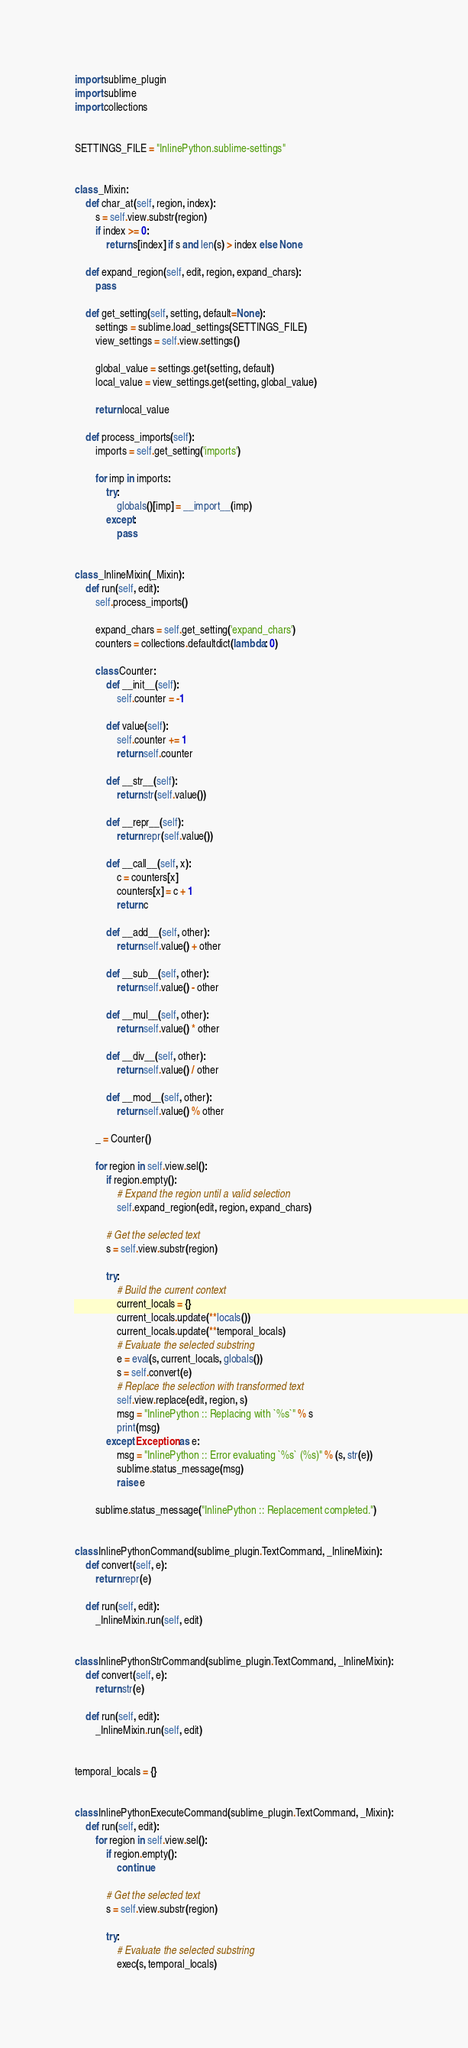<code> <loc_0><loc_0><loc_500><loc_500><_Python_>import sublime_plugin
import sublime
import collections


SETTINGS_FILE = "InlinePython.sublime-settings"


class _Mixin:
    def char_at(self, region, index):
        s = self.view.substr(region)
        if index >= 0:
            return s[index] if s and len(s) > index else None

    def expand_region(self, edit, region, expand_chars):
        pass

    def get_setting(self, setting, default=None):
        settings = sublime.load_settings(SETTINGS_FILE)
        view_settings = self.view.settings()

        global_value = settings.get(setting, default)
        local_value = view_settings.get(setting, global_value)

        return local_value

    def process_imports(self):
        imports = self.get_setting('imports')

        for imp in imports:
            try:
                globals()[imp] = __import__(imp)
            except:
                pass


class _InlineMixin(_Mixin):
    def run(self, edit):
        self.process_imports()

        expand_chars = self.get_setting('expand_chars')
        counters = collections.defaultdict(lambda: 0)

        class Counter:
            def __init__(self):
                self.counter = -1

            def value(self):
                self.counter += 1
                return self.counter

            def __str__(self):
                return str(self.value())

            def __repr__(self):
                return repr(self.value())

            def __call__(self, x):
                c = counters[x]
                counters[x] = c + 1
                return c

            def __add__(self, other):
                return self.value() + other

            def __sub__(self, other):
                return self.value() - other

            def __mul__(self, other):
                return self.value() * other

            def __div__(self, other):
                return self.value() / other

            def __mod__(self, other):
                return self.value() % other

        _ = Counter()

        for region in self.view.sel():
            if region.empty():
                # Expand the region until a valid selection
                self.expand_region(edit, region, expand_chars)

            # Get the selected text
            s = self.view.substr(region)

            try:
                # Build the current context
                current_locals = {}
                current_locals.update(**locals())
                current_locals.update(**temporal_locals)
                # Evaluate the selected substring
                e = eval(s, current_locals, globals())
                s = self.convert(e)
                # Replace the selection with transformed text
                self.view.replace(edit, region, s)
                msg = "InlinePython :: Replacing with `%s`" % s
                print(msg)
            except Exception as e:
                msg = "InlinePython :: Error evaluating `%s` (%s)" % (s, str(e))
                sublime.status_message(msg)
                raise e

        sublime.status_message("InlinePython :: Replacement completed.")


class InlinePythonCommand(sublime_plugin.TextCommand, _InlineMixin):
    def convert(self, e):
        return repr(e)

    def run(self, edit):
        _InlineMixin.run(self, edit)


class InlinePythonStrCommand(sublime_plugin.TextCommand, _InlineMixin):
    def convert(self, e):
        return str(e)

    def run(self, edit):
        _InlineMixin.run(self, edit)


temporal_locals = {}


class InlinePythonExecuteCommand(sublime_plugin.TextCommand, _Mixin):
    def run(self, edit):
        for region in self.view.sel():
            if region.empty():
                continue

            # Get the selected text
            s = self.view.substr(region)

            try:
                # Evaluate the selected substring
                exec(s, temporal_locals)</code> 